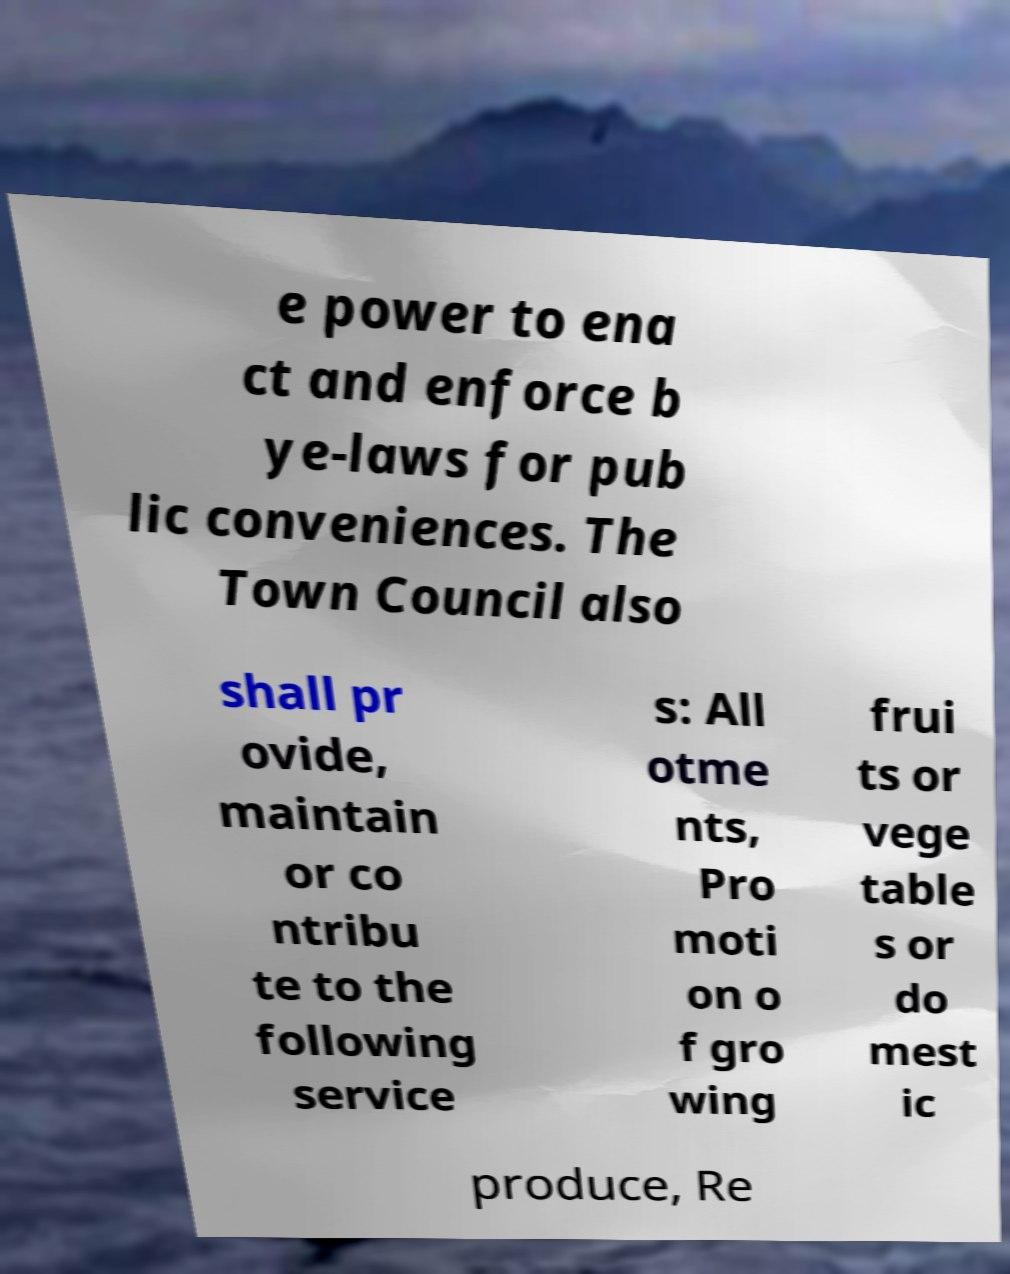Can you read and provide the text displayed in the image?This photo seems to have some interesting text. Can you extract and type it out for me? e power to ena ct and enforce b ye-laws for pub lic conveniences. The Town Council also shall pr ovide, maintain or co ntribu te to the following service s: All otme nts, Pro moti on o f gro wing frui ts or vege table s or do mest ic produce, Re 